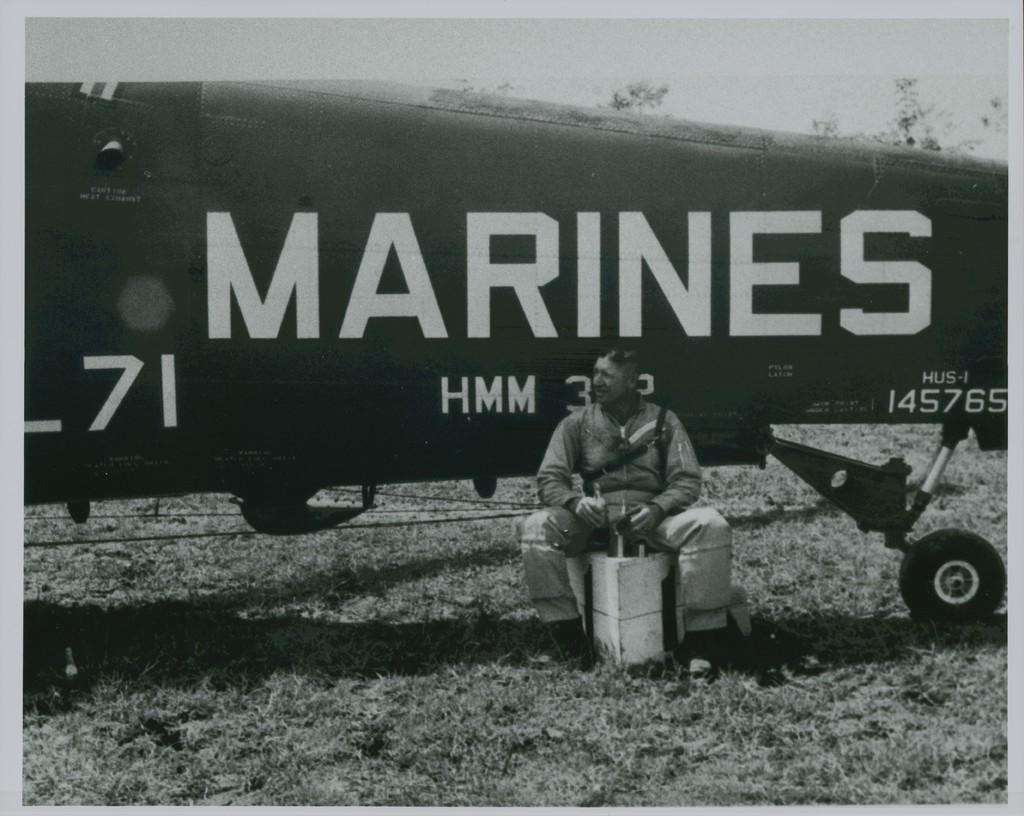<image>
Offer a succinct explanation of the picture presented. Airplane with Marines and HMM designed on the left side. 